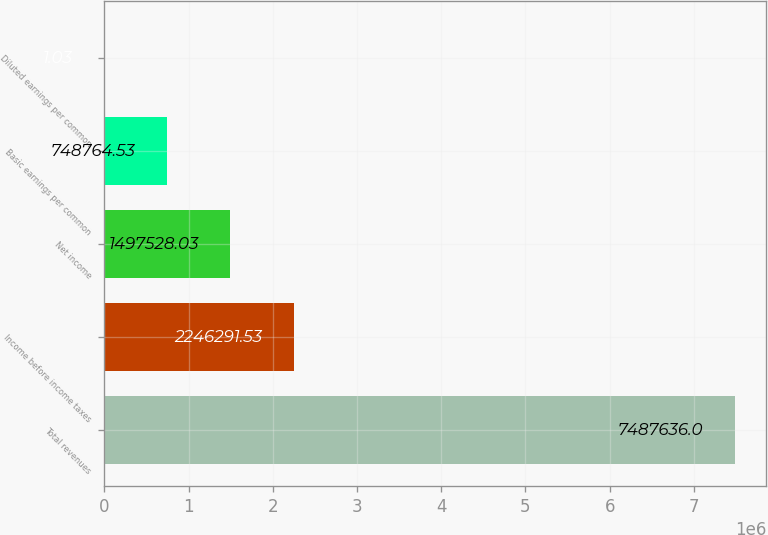Convert chart to OTSL. <chart><loc_0><loc_0><loc_500><loc_500><bar_chart><fcel>Total revenues<fcel>Income before income taxes<fcel>Net income<fcel>Basic earnings per common<fcel>Diluted earnings per common<nl><fcel>7.48764e+06<fcel>2.24629e+06<fcel>1.49753e+06<fcel>748765<fcel>1.03<nl></chart> 